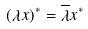<formula> <loc_0><loc_0><loc_500><loc_500>( \lambda x ) ^ { * } = \overline { \lambda } x ^ { * }</formula> 